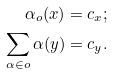<formula> <loc_0><loc_0><loc_500><loc_500>\alpha _ { o } ( x ) & = c _ { x } ; \\ \sum _ { \alpha \in o } \alpha ( y ) & = c _ { y } .</formula> 